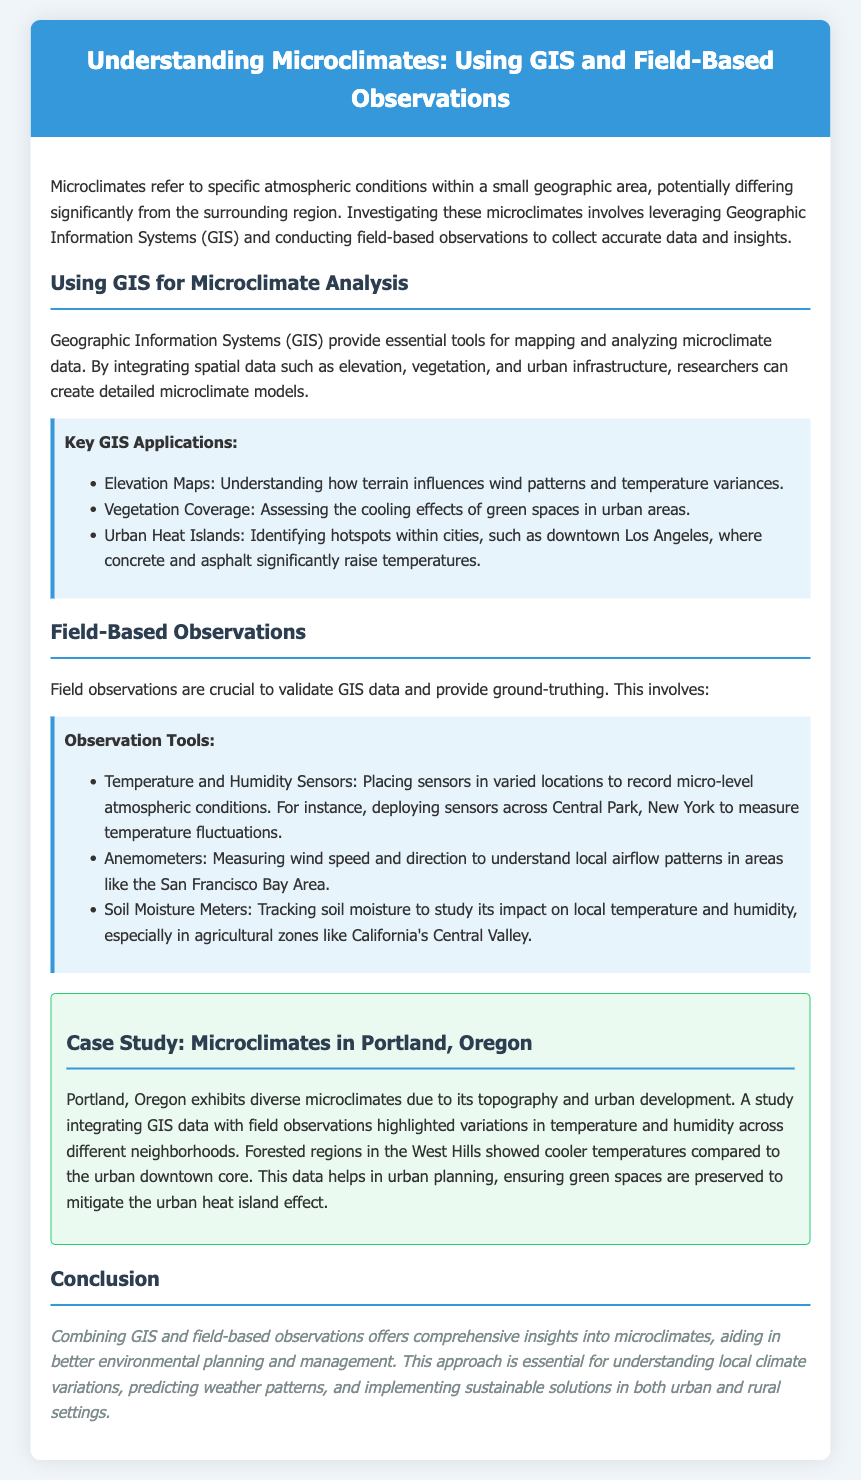What are microclimates? Microclimates refer to specific atmospheric conditions within a small geographic area, potentially differing significantly from the surrounding region.
Answer: Specific atmospheric conditions What does GIS stand for? GIS stands for Geographic Information Systems, which are essential tools for mapping and analyzing microclimate data.
Answer: Geographic Information Systems What is one key application of GIS mentioned? One key GIS application mentioned is Elevation Maps, which help understand how terrain influences wind patterns and temperature variances.
Answer: Elevation Maps Name one tool used for field observations. One tool used for field observations is Temperature and Humidity Sensors, which record micro-level atmospheric conditions.
Answer: Temperature and Humidity Sensors What did the case study in Portland, Oregon highlight? The case study highlighted variations in temperature and humidity across different neighborhoods in Portland.
Answer: Variations in temperature and humidity What is a major consequence of urban development in cities? A major consequence mentioned is the Urban Heat Island effect, where temperatures significantly increase in urban areas compared to surrounding regions.
Answer: Urban Heat Island effect How are field observations validated? Field observations are crucial to validate GIS data and provide ground-truthing.
Answer: Validate GIS data What environmental issue does the conclusion suggest addressing? The conclusion suggests addressing local climate variations for better environmental planning and management.
Answer: Local climate variations 